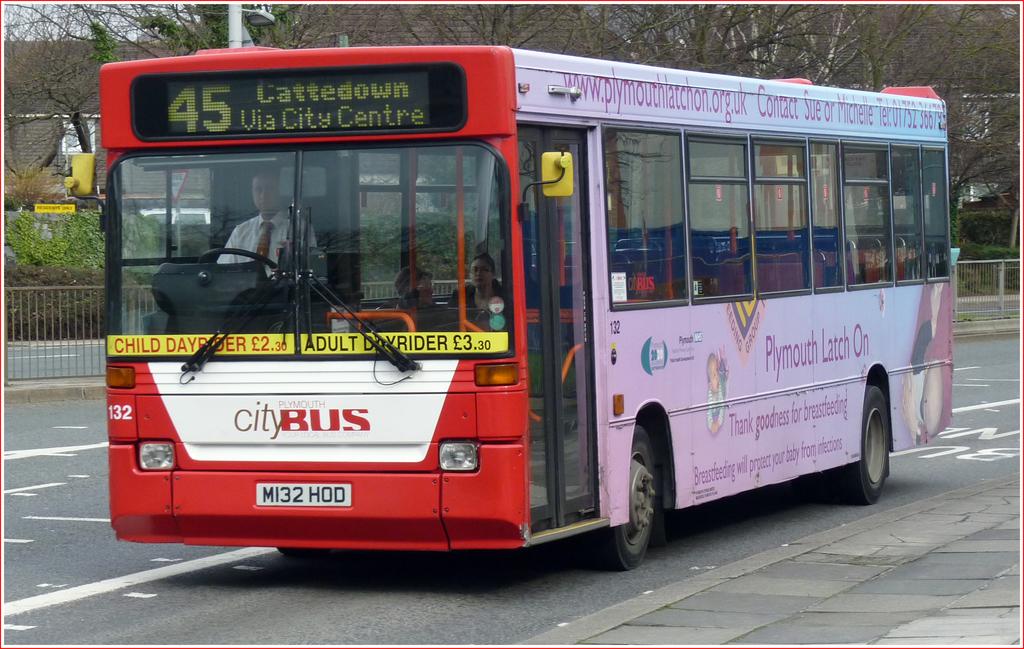What kind of bus is this?
Your answer should be very brief. City. 